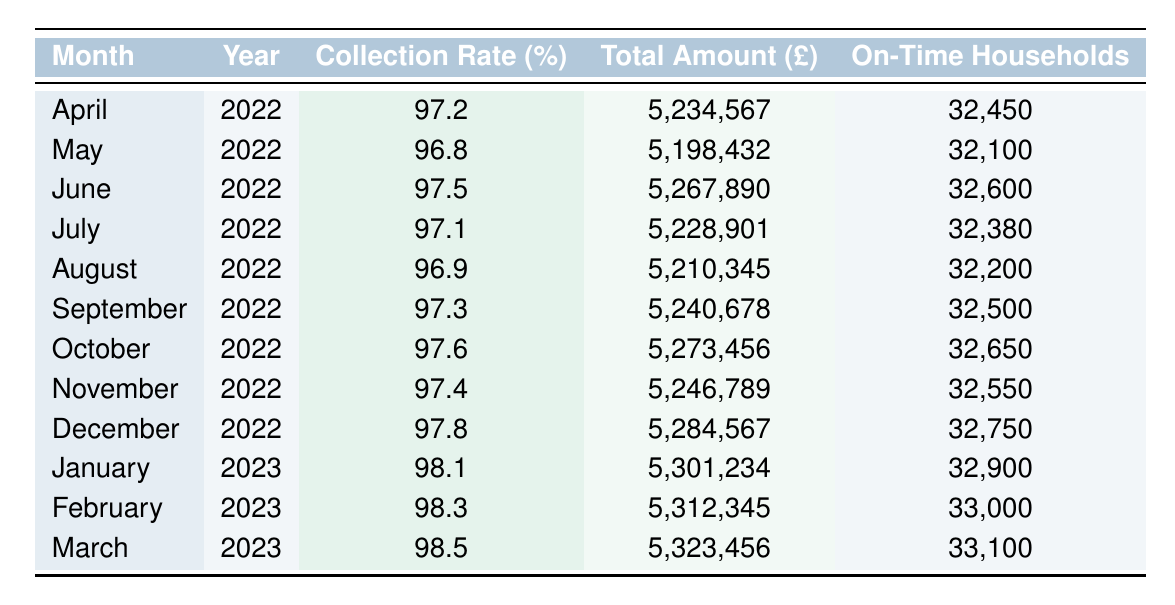What was the collection rate in March 2023? The table lists the collection rate for March 2023 as 98.5%.
Answer: 98.5% Which month had the highest total amount collected? In the table, the highest total amount collected is £5,323,456, which occurred in March 2023.
Answer: March 2023 What is the average collection rate for the first six months of 2022? The collection rates for the first six months of 2022 are 97.2, 96.8, 97.5, 97.1, 96.9, and 97.3. Adding them gives 582.0, and dividing by 6 results in an average of 97.0%.
Answer: 97.0% Did the total amount collected increase from January 2023 to February 2023? The total collected in January 2023 is £5,301,234 and in February 2023 is £5,312,345, which shows an increase.
Answer: Yes What was the total amount collected in the second half of 2022? Adding the total amounts for July (5,228,901), August (5,210,345), September (5,240,678), October (5,273,456), November (5,246,789), and December (5,284,567) gives a total of £31,484,736 for the second half of 2022.
Answer: £31,484,736 How many households paid on time in December 2022? The table states that in December 2022, 32,750 households paid on time.
Answer: 32,750 What is the difference in collection rates between April 2022 and January 2023? The collection rate in April 2022 is 97.2%, and in January 2023, it is 98.1%. The difference is 98.1 - 97.2 = 0.9%.
Answer: 0.9% What was the trend in collection rates from April 2022 to March 2023? The collection rates from April 2022 to March 2023 show an upward trend, increasing from 97.2% to 98.5%.
Answer: Upward trend How many households paid on time in the first quarter of 2023? In January there were 32,900, in February 33,000, and in March 33,100. Summing these gives 32,900 + 33,000 + 33,100 = 99,000 households paid on time.
Answer: 99,000 Which month had the lowest collection rate in 2022? Among the listed collection rates for 2022, May has the lowest rate of 96.8%.
Answer: May 2022 What is the maximum collection rate recorded in the table? By examining the collection rates, the maximum recorded rate is 98.5% in March 2023.
Answer: 98.5% 